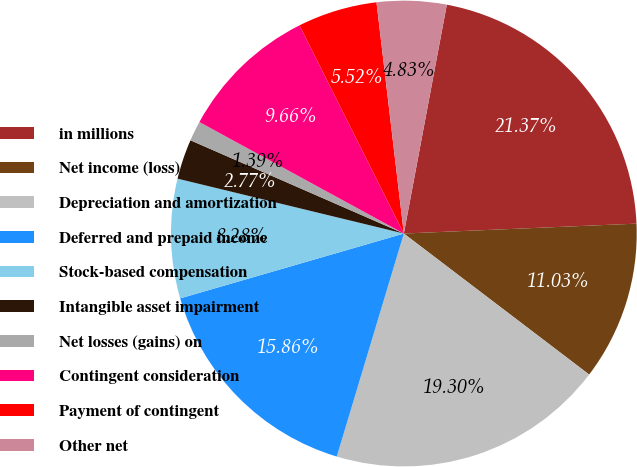Convert chart to OTSL. <chart><loc_0><loc_0><loc_500><loc_500><pie_chart><fcel>in millions<fcel>Net income (loss)<fcel>Depreciation and amortization<fcel>Deferred and prepaid income<fcel>Stock-based compensation<fcel>Intangible asset impairment<fcel>Net losses (gains) on<fcel>Contingent consideration<fcel>Payment of contingent<fcel>Other net<nl><fcel>21.37%<fcel>11.03%<fcel>19.3%<fcel>15.86%<fcel>8.28%<fcel>2.77%<fcel>1.39%<fcel>9.66%<fcel>5.52%<fcel>4.83%<nl></chart> 